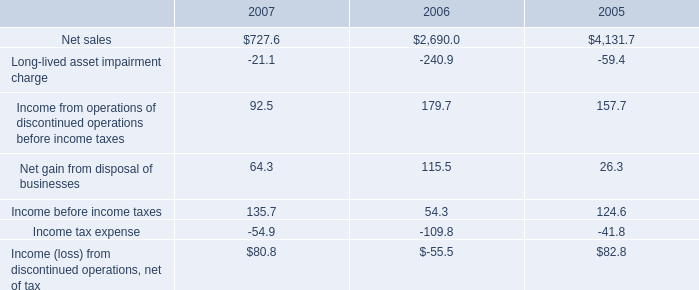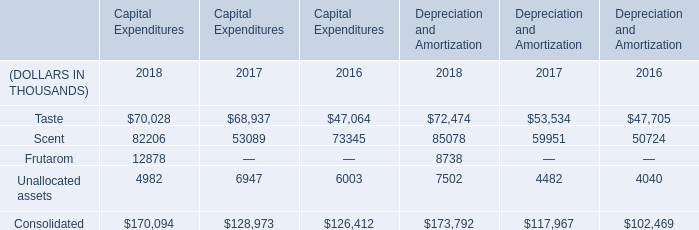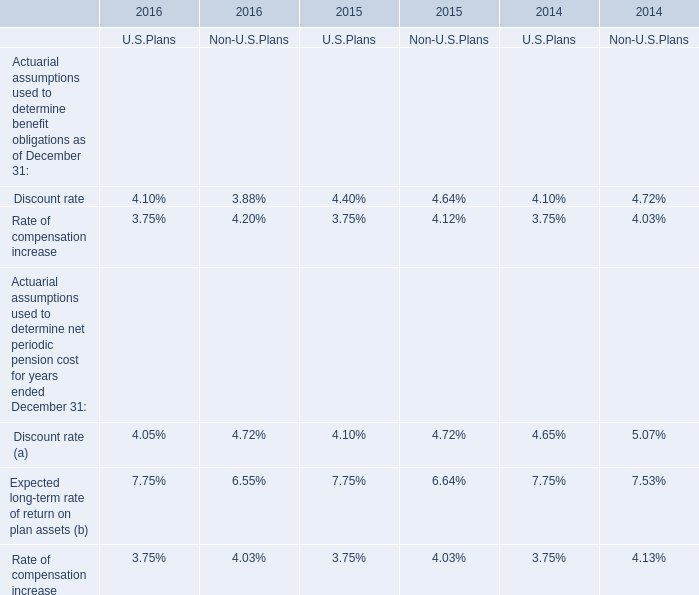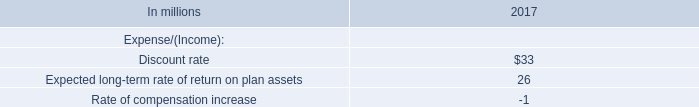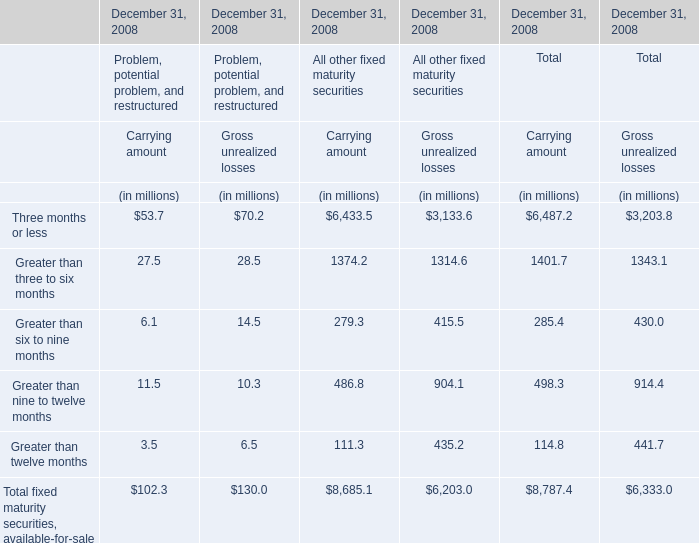What's the 10 % of total carrying amount in 2018? (in million) 
Computations: (8787.4 * 0.1)
Answer: 878.74. 